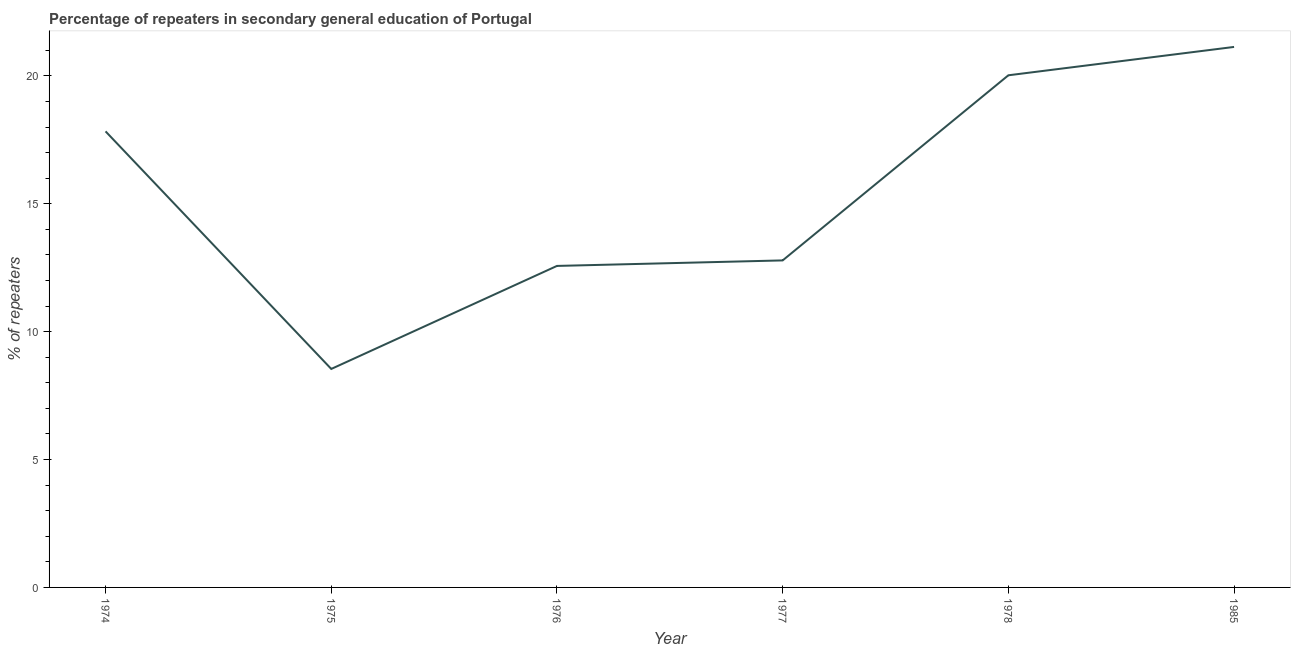What is the percentage of repeaters in 1985?
Your answer should be compact. 21.14. Across all years, what is the maximum percentage of repeaters?
Your response must be concise. 21.14. Across all years, what is the minimum percentage of repeaters?
Provide a short and direct response. 8.54. In which year was the percentage of repeaters minimum?
Offer a very short reply. 1975. What is the sum of the percentage of repeaters?
Your response must be concise. 92.9. What is the difference between the percentage of repeaters in 1975 and 1976?
Offer a terse response. -4.03. What is the average percentage of repeaters per year?
Your response must be concise. 15.48. What is the median percentage of repeaters?
Ensure brevity in your answer.  15.31. In how many years, is the percentage of repeaters greater than 10 %?
Offer a terse response. 5. Do a majority of the years between 1985 and 1978 (inclusive) have percentage of repeaters greater than 15 %?
Your response must be concise. No. What is the ratio of the percentage of repeaters in 1975 to that in 1976?
Keep it short and to the point. 0.68. Is the percentage of repeaters in 1974 less than that in 1977?
Give a very brief answer. No. Is the difference between the percentage of repeaters in 1974 and 1985 greater than the difference between any two years?
Your answer should be compact. No. What is the difference between the highest and the second highest percentage of repeaters?
Your answer should be compact. 1.11. Is the sum of the percentage of repeaters in 1976 and 1978 greater than the maximum percentage of repeaters across all years?
Ensure brevity in your answer.  Yes. What is the difference between the highest and the lowest percentage of repeaters?
Provide a succinct answer. 12.59. In how many years, is the percentage of repeaters greater than the average percentage of repeaters taken over all years?
Provide a succinct answer. 3. Does the percentage of repeaters monotonically increase over the years?
Make the answer very short. No. How many lines are there?
Keep it short and to the point. 1. How many years are there in the graph?
Provide a short and direct response. 6. Are the values on the major ticks of Y-axis written in scientific E-notation?
Keep it short and to the point. No. What is the title of the graph?
Provide a short and direct response. Percentage of repeaters in secondary general education of Portugal. What is the label or title of the X-axis?
Ensure brevity in your answer.  Year. What is the label or title of the Y-axis?
Keep it short and to the point. % of repeaters. What is the % of repeaters in 1974?
Make the answer very short. 17.83. What is the % of repeaters of 1975?
Your answer should be very brief. 8.54. What is the % of repeaters in 1976?
Give a very brief answer. 12.57. What is the % of repeaters in 1977?
Offer a very short reply. 12.79. What is the % of repeaters in 1978?
Ensure brevity in your answer.  20.03. What is the % of repeaters of 1985?
Your answer should be compact. 21.14. What is the difference between the % of repeaters in 1974 and 1975?
Your answer should be very brief. 9.29. What is the difference between the % of repeaters in 1974 and 1976?
Keep it short and to the point. 5.26. What is the difference between the % of repeaters in 1974 and 1977?
Keep it short and to the point. 5.05. What is the difference between the % of repeaters in 1974 and 1978?
Your answer should be very brief. -2.19. What is the difference between the % of repeaters in 1974 and 1985?
Provide a short and direct response. -3.3. What is the difference between the % of repeaters in 1975 and 1976?
Give a very brief answer. -4.03. What is the difference between the % of repeaters in 1975 and 1977?
Make the answer very short. -4.24. What is the difference between the % of repeaters in 1975 and 1978?
Offer a very short reply. -11.48. What is the difference between the % of repeaters in 1975 and 1985?
Your answer should be very brief. -12.59. What is the difference between the % of repeaters in 1976 and 1977?
Ensure brevity in your answer.  -0.22. What is the difference between the % of repeaters in 1976 and 1978?
Provide a succinct answer. -7.45. What is the difference between the % of repeaters in 1976 and 1985?
Ensure brevity in your answer.  -8.56. What is the difference between the % of repeaters in 1977 and 1978?
Your answer should be compact. -7.24. What is the difference between the % of repeaters in 1977 and 1985?
Your answer should be very brief. -8.35. What is the difference between the % of repeaters in 1978 and 1985?
Give a very brief answer. -1.11. What is the ratio of the % of repeaters in 1974 to that in 1975?
Ensure brevity in your answer.  2.09. What is the ratio of the % of repeaters in 1974 to that in 1976?
Ensure brevity in your answer.  1.42. What is the ratio of the % of repeaters in 1974 to that in 1977?
Your answer should be compact. 1.4. What is the ratio of the % of repeaters in 1974 to that in 1978?
Keep it short and to the point. 0.89. What is the ratio of the % of repeaters in 1974 to that in 1985?
Give a very brief answer. 0.84. What is the ratio of the % of repeaters in 1975 to that in 1976?
Provide a succinct answer. 0.68. What is the ratio of the % of repeaters in 1975 to that in 1977?
Make the answer very short. 0.67. What is the ratio of the % of repeaters in 1975 to that in 1978?
Your answer should be very brief. 0.43. What is the ratio of the % of repeaters in 1975 to that in 1985?
Ensure brevity in your answer.  0.4. What is the ratio of the % of repeaters in 1976 to that in 1977?
Your answer should be compact. 0.98. What is the ratio of the % of repeaters in 1976 to that in 1978?
Your answer should be compact. 0.63. What is the ratio of the % of repeaters in 1976 to that in 1985?
Keep it short and to the point. 0.59. What is the ratio of the % of repeaters in 1977 to that in 1978?
Your answer should be very brief. 0.64. What is the ratio of the % of repeaters in 1977 to that in 1985?
Your answer should be compact. 0.6. What is the ratio of the % of repeaters in 1978 to that in 1985?
Provide a short and direct response. 0.95. 